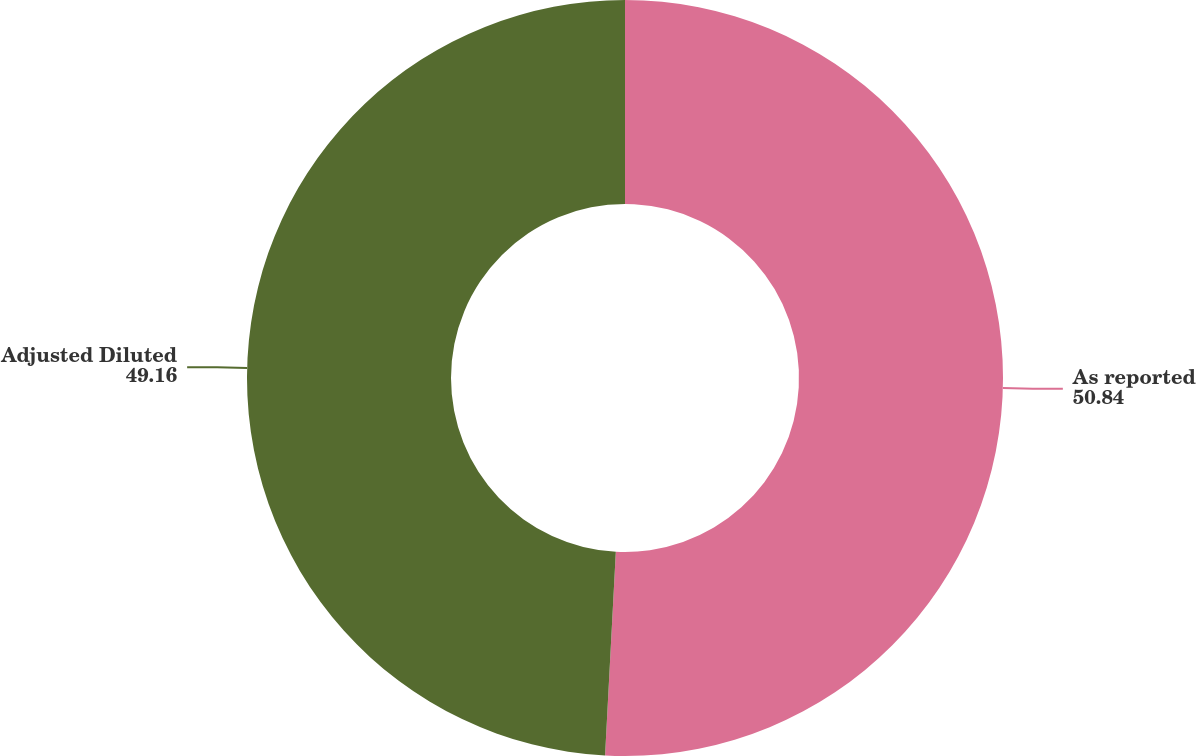Convert chart. <chart><loc_0><loc_0><loc_500><loc_500><pie_chart><fcel>As reported<fcel>Adjusted Diluted<nl><fcel>50.84%<fcel>49.16%<nl></chart> 